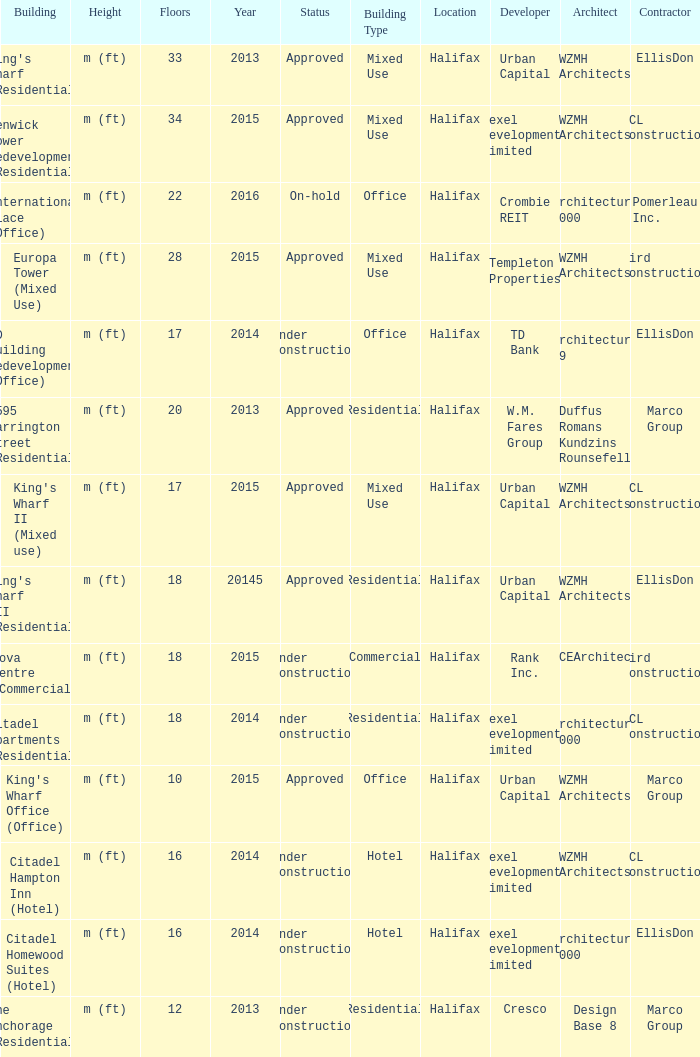What is the status of the building with more than 28 floor and a year of 2013? Approved. Could you help me parse every detail presented in this table? {'header': ['Building', 'Height', 'Floors', 'Year', 'Status', 'Building Type', 'Location', 'Developer', 'Architect', 'Contractor'], 'rows': [["King's Wharf (Residential)", 'm (ft)', '33', '2013', 'Approved', 'Mixed Use', 'Halifax', 'Urban Capital', 'WZMH Architects', 'EllisDon'], ['Fenwick Tower Redevelopment (Residential)', 'm (ft)', '34', '2015', 'Approved', 'Mixed Use', 'Halifax', 'Dexel Developments Limited', 'WZMH Architects', 'PCL Construction'], ['International Place (Office)', 'm (ft)', '22', '2016', 'On-hold', 'Office', 'Halifax', 'Crombie REIT', 'Architecture 2000', 'Pomerleau Inc.'], ['Europa Tower (Mixed Use)', 'm (ft)', '28', '2015', 'Approved', 'Mixed Use', 'Halifax', 'Templeton Properties', 'WZMH Architects', 'Bird Construction'], ['TD Building Redevelopment (Office)', 'm (ft)', '17', '2014', 'Under Construction', 'Office', 'Halifax', 'TD Bank', 'Architecture 49', 'EllisDon'], ['1595 Barrington Street (Residential)', 'm (ft)', '20', '2013', 'Approved', 'Residential', 'Halifax', 'W.M. Fares Group', 'Duffus Romans Kundzins Rounsefell', 'Marco Group'], ["King's Wharf II (Mixed use)", 'm (ft)', '17', '2015', 'Approved', 'Mixed Use', 'Halifax', 'Urban Capital', 'WZMH Architects', 'PCL Construction'], ["King's Wharf III (Residential)", 'm (ft)', '18', '20145', 'Approved', 'Residential', 'Halifax', 'Urban Capital', 'WZMH Architects', 'EllisDon'], ['Nova Centre (Commercial)', 'm (ft)', '18', '2015', 'Under Construction', 'Commercial', 'Halifax', 'Rank Inc.', 'FBCEArchitects', 'Bird Construction'], ['Citadel Apartments (Residential)', 'm (ft)', '18', '2014', 'Under Construction', 'Residential', 'Halifax', 'Dexel Developments Limited', 'Architecture 2000', 'PCL Construction'], ["King's Wharf Office (Office)", 'm (ft)', '10', '2015', 'Approved', 'Office', 'Halifax', 'Urban Capital', 'WZMH Architects', 'Marco Group'], ['Citadel Hampton Inn (Hotel)', 'm (ft)', '16', '2014', 'Under Construction', 'Hotel', 'Halifax', 'Dexel Developments Limited', 'WZMH Architects', 'PCL Construction'], ['Citadel Homewood Suites (Hotel)', 'm (ft)', '16', '2014', 'Under Construction', 'Hotel', 'Halifax', 'Dexel Developments Limited', 'Architecture 2000', 'EllisDon'], ['The Anchorage (Residential)', 'm (ft)', '12', '2013', 'Under construction', 'Residential', 'Halifax', 'Cresco', 'Design Base 8', 'Marco Group']]} 